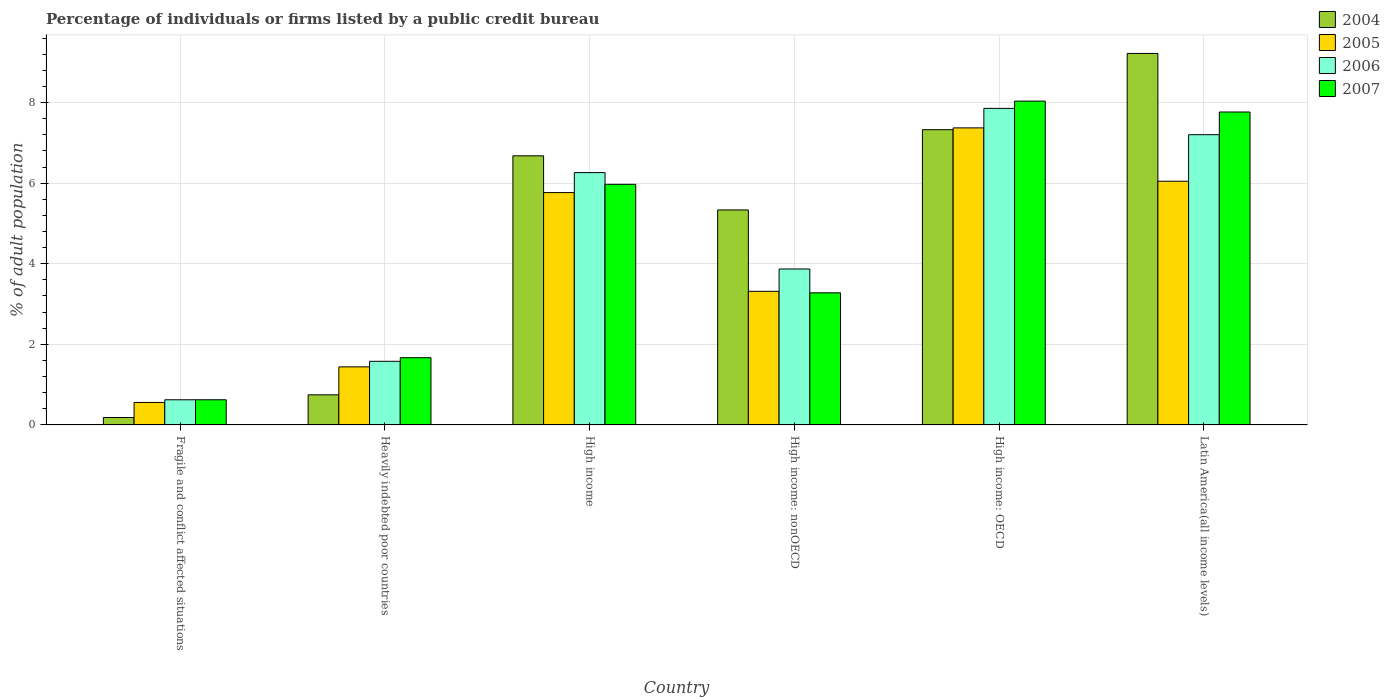How many different coloured bars are there?
Offer a very short reply. 4. How many bars are there on the 4th tick from the left?
Keep it short and to the point. 4. How many bars are there on the 3rd tick from the right?
Offer a terse response. 4. What is the label of the 2nd group of bars from the left?
Your answer should be compact. Heavily indebted poor countries. In how many cases, is the number of bars for a given country not equal to the number of legend labels?
Your response must be concise. 0. What is the percentage of population listed by a public credit bureau in 2007 in High income: nonOECD?
Your answer should be compact. 3.28. Across all countries, what is the maximum percentage of population listed by a public credit bureau in 2007?
Provide a succinct answer. 8.04. Across all countries, what is the minimum percentage of population listed by a public credit bureau in 2004?
Offer a terse response. 0.18. In which country was the percentage of population listed by a public credit bureau in 2006 maximum?
Ensure brevity in your answer.  High income: OECD. In which country was the percentage of population listed by a public credit bureau in 2005 minimum?
Your answer should be very brief. Fragile and conflict affected situations. What is the total percentage of population listed by a public credit bureau in 2004 in the graph?
Give a very brief answer. 29.49. What is the difference between the percentage of population listed by a public credit bureau in 2006 in Fragile and conflict affected situations and that in High income: OECD?
Your answer should be compact. -7.23. What is the difference between the percentage of population listed by a public credit bureau in 2005 in Fragile and conflict affected situations and the percentage of population listed by a public credit bureau in 2007 in Heavily indebted poor countries?
Provide a succinct answer. -1.11. What is the average percentage of population listed by a public credit bureau in 2005 per country?
Keep it short and to the point. 4.08. What is the difference between the percentage of population listed by a public credit bureau of/in 2007 and percentage of population listed by a public credit bureau of/in 2004 in Fragile and conflict affected situations?
Provide a succinct answer. 0.44. What is the ratio of the percentage of population listed by a public credit bureau in 2006 in High income: OECD to that in High income: nonOECD?
Keep it short and to the point. 2.03. Is the difference between the percentage of population listed by a public credit bureau in 2007 in Heavily indebted poor countries and High income greater than the difference between the percentage of population listed by a public credit bureau in 2004 in Heavily indebted poor countries and High income?
Offer a terse response. Yes. What is the difference between the highest and the second highest percentage of population listed by a public credit bureau in 2005?
Keep it short and to the point. -0.28. What is the difference between the highest and the lowest percentage of population listed by a public credit bureau in 2004?
Your response must be concise. 9.04. In how many countries, is the percentage of population listed by a public credit bureau in 2007 greater than the average percentage of population listed by a public credit bureau in 2007 taken over all countries?
Ensure brevity in your answer.  3. Is the sum of the percentage of population listed by a public credit bureau in 2007 in High income and Latin America(all income levels) greater than the maximum percentage of population listed by a public credit bureau in 2006 across all countries?
Your response must be concise. Yes. What does the 4th bar from the left in Latin America(all income levels) represents?
Provide a short and direct response. 2007. What does the 2nd bar from the right in High income represents?
Your answer should be compact. 2006. Is it the case that in every country, the sum of the percentage of population listed by a public credit bureau in 2007 and percentage of population listed by a public credit bureau in 2005 is greater than the percentage of population listed by a public credit bureau in 2006?
Keep it short and to the point. Yes. How many countries are there in the graph?
Provide a short and direct response. 6. What is the difference between two consecutive major ticks on the Y-axis?
Offer a very short reply. 2. Are the values on the major ticks of Y-axis written in scientific E-notation?
Keep it short and to the point. No. Does the graph contain any zero values?
Your response must be concise. No. How many legend labels are there?
Provide a succinct answer. 4. How are the legend labels stacked?
Make the answer very short. Vertical. What is the title of the graph?
Make the answer very short. Percentage of individuals or firms listed by a public credit bureau. What is the label or title of the X-axis?
Provide a succinct answer. Country. What is the label or title of the Y-axis?
Give a very brief answer. % of adult population. What is the % of adult population of 2004 in Fragile and conflict affected situations?
Offer a terse response. 0.18. What is the % of adult population in 2005 in Fragile and conflict affected situations?
Make the answer very short. 0.56. What is the % of adult population of 2006 in Fragile and conflict affected situations?
Your response must be concise. 0.62. What is the % of adult population in 2007 in Fragile and conflict affected situations?
Provide a short and direct response. 0.62. What is the % of adult population of 2004 in Heavily indebted poor countries?
Your answer should be very brief. 0.75. What is the % of adult population in 2005 in Heavily indebted poor countries?
Your answer should be compact. 1.44. What is the % of adult population in 2006 in Heavily indebted poor countries?
Make the answer very short. 1.58. What is the % of adult population in 2007 in Heavily indebted poor countries?
Offer a terse response. 1.67. What is the % of adult population of 2004 in High income?
Ensure brevity in your answer.  6.68. What is the % of adult population of 2005 in High income?
Give a very brief answer. 5.77. What is the % of adult population of 2006 in High income?
Give a very brief answer. 6.26. What is the % of adult population in 2007 in High income?
Provide a succinct answer. 5.97. What is the % of adult population in 2004 in High income: nonOECD?
Give a very brief answer. 5.34. What is the % of adult population in 2005 in High income: nonOECD?
Offer a very short reply. 3.32. What is the % of adult population in 2006 in High income: nonOECD?
Offer a terse response. 3.87. What is the % of adult population in 2007 in High income: nonOECD?
Your response must be concise. 3.28. What is the % of adult population in 2004 in High income: OECD?
Your answer should be very brief. 7.33. What is the % of adult population in 2005 in High income: OECD?
Your response must be concise. 7.37. What is the % of adult population of 2006 in High income: OECD?
Your answer should be very brief. 7.86. What is the % of adult population in 2007 in High income: OECD?
Your answer should be compact. 8.04. What is the % of adult population in 2004 in Latin America(all income levels)?
Ensure brevity in your answer.  9.22. What is the % of adult population of 2005 in Latin America(all income levels)?
Keep it short and to the point. 6.05. What is the % of adult population of 2006 in Latin America(all income levels)?
Offer a terse response. 7.2. What is the % of adult population of 2007 in Latin America(all income levels)?
Ensure brevity in your answer.  7.77. Across all countries, what is the maximum % of adult population in 2004?
Keep it short and to the point. 9.22. Across all countries, what is the maximum % of adult population of 2005?
Your response must be concise. 7.37. Across all countries, what is the maximum % of adult population in 2006?
Give a very brief answer. 7.86. Across all countries, what is the maximum % of adult population of 2007?
Keep it short and to the point. 8.04. Across all countries, what is the minimum % of adult population in 2004?
Make the answer very short. 0.18. Across all countries, what is the minimum % of adult population in 2005?
Your answer should be very brief. 0.56. Across all countries, what is the minimum % of adult population of 2006?
Offer a terse response. 0.62. Across all countries, what is the minimum % of adult population in 2007?
Your answer should be very brief. 0.62. What is the total % of adult population of 2004 in the graph?
Offer a terse response. 29.49. What is the total % of adult population of 2005 in the graph?
Your answer should be very brief. 24.5. What is the total % of adult population of 2006 in the graph?
Provide a succinct answer. 27.4. What is the total % of adult population of 2007 in the graph?
Provide a succinct answer. 27.35. What is the difference between the % of adult population in 2004 in Fragile and conflict affected situations and that in Heavily indebted poor countries?
Provide a short and direct response. -0.56. What is the difference between the % of adult population of 2005 in Fragile and conflict affected situations and that in Heavily indebted poor countries?
Ensure brevity in your answer.  -0.88. What is the difference between the % of adult population of 2006 in Fragile and conflict affected situations and that in Heavily indebted poor countries?
Give a very brief answer. -0.95. What is the difference between the % of adult population in 2007 in Fragile and conflict affected situations and that in Heavily indebted poor countries?
Give a very brief answer. -1.04. What is the difference between the % of adult population of 2004 in Fragile and conflict affected situations and that in High income?
Provide a succinct answer. -6.5. What is the difference between the % of adult population of 2005 in Fragile and conflict affected situations and that in High income?
Offer a terse response. -5.21. What is the difference between the % of adult population in 2006 in Fragile and conflict affected situations and that in High income?
Give a very brief answer. -5.64. What is the difference between the % of adult population in 2007 in Fragile and conflict affected situations and that in High income?
Offer a very short reply. -5.35. What is the difference between the % of adult population in 2004 in Fragile and conflict affected situations and that in High income: nonOECD?
Make the answer very short. -5.15. What is the difference between the % of adult population of 2005 in Fragile and conflict affected situations and that in High income: nonOECD?
Offer a terse response. -2.76. What is the difference between the % of adult population in 2006 in Fragile and conflict affected situations and that in High income: nonOECD?
Offer a terse response. -3.25. What is the difference between the % of adult population of 2007 in Fragile and conflict affected situations and that in High income: nonOECD?
Your answer should be very brief. -2.65. What is the difference between the % of adult population of 2004 in Fragile and conflict affected situations and that in High income: OECD?
Your answer should be compact. -7.14. What is the difference between the % of adult population in 2005 in Fragile and conflict affected situations and that in High income: OECD?
Offer a very short reply. -6.82. What is the difference between the % of adult population in 2006 in Fragile and conflict affected situations and that in High income: OECD?
Offer a terse response. -7.23. What is the difference between the % of adult population in 2007 in Fragile and conflict affected situations and that in High income: OECD?
Provide a succinct answer. -7.41. What is the difference between the % of adult population in 2004 in Fragile and conflict affected situations and that in Latin America(all income levels)?
Your answer should be very brief. -9.04. What is the difference between the % of adult population in 2005 in Fragile and conflict affected situations and that in Latin America(all income levels)?
Provide a succinct answer. -5.49. What is the difference between the % of adult population in 2006 in Fragile and conflict affected situations and that in Latin America(all income levels)?
Provide a short and direct response. -6.58. What is the difference between the % of adult population in 2007 in Fragile and conflict affected situations and that in Latin America(all income levels)?
Your response must be concise. -7.14. What is the difference between the % of adult population in 2004 in Heavily indebted poor countries and that in High income?
Ensure brevity in your answer.  -5.93. What is the difference between the % of adult population in 2005 in Heavily indebted poor countries and that in High income?
Provide a succinct answer. -4.33. What is the difference between the % of adult population in 2006 in Heavily indebted poor countries and that in High income?
Make the answer very short. -4.68. What is the difference between the % of adult population in 2007 in Heavily indebted poor countries and that in High income?
Provide a short and direct response. -4.3. What is the difference between the % of adult population in 2004 in Heavily indebted poor countries and that in High income: nonOECD?
Offer a terse response. -4.59. What is the difference between the % of adult population in 2005 in Heavily indebted poor countries and that in High income: nonOECD?
Provide a short and direct response. -1.88. What is the difference between the % of adult population in 2006 in Heavily indebted poor countries and that in High income: nonOECD?
Your answer should be very brief. -2.29. What is the difference between the % of adult population in 2007 in Heavily indebted poor countries and that in High income: nonOECD?
Your answer should be compact. -1.61. What is the difference between the % of adult population of 2004 in Heavily indebted poor countries and that in High income: OECD?
Provide a succinct answer. -6.58. What is the difference between the % of adult population of 2005 in Heavily indebted poor countries and that in High income: OECD?
Your answer should be compact. -5.93. What is the difference between the % of adult population of 2006 in Heavily indebted poor countries and that in High income: OECD?
Give a very brief answer. -6.28. What is the difference between the % of adult population of 2007 in Heavily indebted poor countries and that in High income: OECD?
Your answer should be very brief. -6.37. What is the difference between the % of adult population in 2004 in Heavily indebted poor countries and that in Latin America(all income levels)?
Offer a terse response. -8.47. What is the difference between the % of adult population of 2005 in Heavily indebted poor countries and that in Latin America(all income levels)?
Provide a short and direct response. -4.61. What is the difference between the % of adult population in 2006 in Heavily indebted poor countries and that in Latin America(all income levels)?
Offer a very short reply. -5.62. What is the difference between the % of adult population in 2007 in Heavily indebted poor countries and that in Latin America(all income levels)?
Provide a succinct answer. -6.1. What is the difference between the % of adult population in 2004 in High income and that in High income: nonOECD?
Provide a short and direct response. 1.34. What is the difference between the % of adult population of 2005 in High income and that in High income: nonOECD?
Provide a succinct answer. 2.45. What is the difference between the % of adult population in 2006 in High income and that in High income: nonOECD?
Ensure brevity in your answer.  2.39. What is the difference between the % of adult population in 2007 in High income and that in High income: nonOECD?
Give a very brief answer. 2.69. What is the difference between the % of adult population of 2004 in High income and that in High income: OECD?
Provide a short and direct response. -0.65. What is the difference between the % of adult population in 2005 in High income and that in High income: OECD?
Offer a very short reply. -1.61. What is the difference between the % of adult population in 2006 in High income and that in High income: OECD?
Provide a short and direct response. -1.59. What is the difference between the % of adult population of 2007 in High income and that in High income: OECD?
Ensure brevity in your answer.  -2.06. What is the difference between the % of adult population of 2004 in High income and that in Latin America(all income levels)?
Ensure brevity in your answer.  -2.54. What is the difference between the % of adult population in 2005 in High income and that in Latin America(all income levels)?
Your answer should be compact. -0.28. What is the difference between the % of adult population of 2006 in High income and that in Latin America(all income levels)?
Your response must be concise. -0.94. What is the difference between the % of adult population of 2007 in High income and that in Latin America(all income levels)?
Offer a very short reply. -1.79. What is the difference between the % of adult population in 2004 in High income: nonOECD and that in High income: OECD?
Your answer should be very brief. -1.99. What is the difference between the % of adult population in 2005 in High income: nonOECD and that in High income: OECD?
Make the answer very short. -4.06. What is the difference between the % of adult population of 2006 in High income: nonOECD and that in High income: OECD?
Your answer should be compact. -3.99. What is the difference between the % of adult population of 2007 in High income: nonOECD and that in High income: OECD?
Your response must be concise. -4.76. What is the difference between the % of adult population in 2004 in High income: nonOECD and that in Latin America(all income levels)?
Your answer should be compact. -3.88. What is the difference between the % of adult population of 2005 in High income: nonOECD and that in Latin America(all income levels)?
Ensure brevity in your answer.  -2.73. What is the difference between the % of adult population of 2006 in High income: nonOECD and that in Latin America(all income levels)?
Provide a short and direct response. -3.33. What is the difference between the % of adult population in 2007 in High income: nonOECD and that in Latin America(all income levels)?
Your answer should be very brief. -4.49. What is the difference between the % of adult population of 2004 in High income: OECD and that in Latin America(all income levels)?
Offer a terse response. -1.89. What is the difference between the % of adult population of 2005 in High income: OECD and that in Latin America(all income levels)?
Your answer should be very brief. 1.32. What is the difference between the % of adult population in 2006 in High income: OECD and that in Latin America(all income levels)?
Offer a very short reply. 0.65. What is the difference between the % of adult population in 2007 in High income: OECD and that in Latin America(all income levels)?
Offer a very short reply. 0.27. What is the difference between the % of adult population of 2004 in Fragile and conflict affected situations and the % of adult population of 2005 in Heavily indebted poor countries?
Your answer should be very brief. -1.26. What is the difference between the % of adult population of 2004 in Fragile and conflict affected situations and the % of adult population of 2006 in Heavily indebted poor countries?
Provide a succinct answer. -1.39. What is the difference between the % of adult population in 2004 in Fragile and conflict affected situations and the % of adult population in 2007 in Heavily indebted poor countries?
Keep it short and to the point. -1.48. What is the difference between the % of adult population in 2005 in Fragile and conflict affected situations and the % of adult population in 2006 in Heavily indebted poor countries?
Keep it short and to the point. -1.02. What is the difference between the % of adult population in 2005 in Fragile and conflict affected situations and the % of adult population in 2007 in Heavily indebted poor countries?
Your response must be concise. -1.11. What is the difference between the % of adult population of 2006 in Fragile and conflict affected situations and the % of adult population of 2007 in Heavily indebted poor countries?
Give a very brief answer. -1.04. What is the difference between the % of adult population in 2004 in Fragile and conflict affected situations and the % of adult population in 2005 in High income?
Offer a terse response. -5.58. What is the difference between the % of adult population in 2004 in Fragile and conflict affected situations and the % of adult population in 2006 in High income?
Keep it short and to the point. -6.08. What is the difference between the % of adult population of 2004 in Fragile and conflict affected situations and the % of adult population of 2007 in High income?
Give a very brief answer. -5.79. What is the difference between the % of adult population in 2005 in Fragile and conflict affected situations and the % of adult population in 2006 in High income?
Ensure brevity in your answer.  -5.7. What is the difference between the % of adult population in 2005 in Fragile and conflict affected situations and the % of adult population in 2007 in High income?
Offer a very short reply. -5.41. What is the difference between the % of adult population of 2006 in Fragile and conflict affected situations and the % of adult population of 2007 in High income?
Your response must be concise. -5.35. What is the difference between the % of adult population of 2004 in Fragile and conflict affected situations and the % of adult population of 2005 in High income: nonOECD?
Provide a short and direct response. -3.13. What is the difference between the % of adult population of 2004 in Fragile and conflict affected situations and the % of adult population of 2006 in High income: nonOECD?
Make the answer very short. -3.69. What is the difference between the % of adult population of 2004 in Fragile and conflict affected situations and the % of adult population of 2007 in High income: nonOECD?
Make the answer very short. -3.09. What is the difference between the % of adult population in 2005 in Fragile and conflict affected situations and the % of adult population in 2006 in High income: nonOECD?
Provide a short and direct response. -3.31. What is the difference between the % of adult population in 2005 in Fragile and conflict affected situations and the % of adult population in 2007 in High income: nonOECD?
Provide a short and direct response. -2.72. What is the difference between the % of adult population of 2006 in Fragile and conflict affected situations and the % of adult population of 2007 in High income: nonOECD?
Your answer should be very brief. -2.65. What is the difference between the % of adult population in 2004 in Fragile and conflict affected situations and the % of adult population in 2005 in High income: OECD?
Offer a terse response. -7.19. What is the difference between the % of adult population of 2004 in Fragile and conflict affected situations and the % of adult population of 2006 in High income: OECD?
Your answer should be very brief. -7.67. What is the difference between the % of adult population of 2004 in Fragile and conflict affected situations and the % of adult population of 2007 in High income: OECD?
Your answer should be very brief. -7.85. What is the difference between the % of adult population in 2005 in Fragile and conflict affected situations and the % of adult population in 2006 in High income: OECD?
Keep it short and to the point. -7.3. What is the difference between the % of adult population of 2005 in Fragile and conflict affected situations and the % of adult population of 2007 in High income: OECD?
Ensure brevity in your answer.  -7.48. What is the difference between the % of adult population of 2006 in Fragile and conflict affected situations and the % of adult population of 2007 in High income: OECD?
Offer a terse response. -7.41. What is the difference between the % of adult population in 2004 in Fragile and conflict affected situations and the % of adult population in 2005 in Latin America(all income levels)?
Provide a short and direct response. -5.86. What is the difference between the % of adult population of 2004 in Fragile and conflict affected situations and the % of adult population of 2006 in Latin America(all income levels)?
Keep it short and to the point. -7.02. What is the difference between the % of adult population in 2004 in Fragile and conflict affected situations and the % of adult population in 2007 in Latin America(all income levels)?
Give a very brief answer. -7.58. What is the difference between the % of adult population in 2005 in Fragile and conflict affected situations and the % of adult population in 2006 in Latin America(all income levels)?
Your answer should be compact. -6.65. What is the difference between the % of adult population in 2005 in Fragile and conflict affected situations and the % of adult population in 2007 in Latin America(all income levels)?
Your answer should be compact. -7.21. What is the difference between the % of adult population of 2006 in Fragile and conflict affected situations and the % of adult population of 2007 in Latin America(all income levels)?
Provide a short and direct response. -7.14. What is the difference between the % of adult population of 2004 in Heavily indebted poor countries and the % of adult population of 2005 in High income?
Offer a terse response. -5.02. What is the difference between the % of adult population in 2004 in Heavily indebted poor countries and the % of adult population in 2006 in High income?
Make the answer very short. -5.51. What is the difference between the % of adult population in 2004 in Heavily indebted poor countries and the % of adult population in 2007 in High income?
Offer a terse response. -5.22. What is the difference between the % of adult population of 2005 in Heavily indebted poor countries and the % of adult population of 2006 in High income?
Offer a very short reply. -4.82. What is the difference between the % of adult population of 2005 in Heavily indebted poor countries and the % of adult population of 2007 in High income?
Your answer should be very brief. -4.53. What is the difference between the % of adult population in 2006 in Heavily indebted poor countries and the % of adult population in 2007 in High income?
Provide a short and direct response. -4.39. What is the difference between the % of adult population of 2004 in Heavily indebted poor countries and the % of adult population of 2005 in High income: nonOECD?
Provide a succinct answer. -2.57. What is the difference between the % of adult population in 2004 in Heavily indebted poor countries and the % of adult population in 2006 in High income: nonOECD?
Give a very brief answer. -3.12. What is the difference between the % of adult population of 2004 in Heavily indebted poor countries and the % of adult population of 2007 in High income: nonOECD?
Your answer should be compact. -2.53. What is the difference between the % of adult population of 2005 in Heavily indebted poor countries and the % of adult population of 2006 in High income: nonOECD?
Provide a short and direct response. -2.43. What is the difference between the % of adult population in 2005 in Heavily indebted poor countries and the % of adult population in 2007 in High income: nonOECD?
Offer a very short reply. -1.84. What is the difference between the % of adult population of 2006 in Heavily indebted poor countries and the % of adult population of 2007 in High income: nonOECD?
Ensure brevity in your answer.  -1.7. What is the difference between the % of adult population in 2004 in Heavily indebted poor countries and the % of adult population in 2005 in High income: OECD?
Keep it short and to the point. -6.63. What is the difference between the % of adult population of 2004 in Heavily indebted poor countries and the % of adult population of 2006 in High income: OECD?
Ensure brevity in your answer.  -7.11. What is the difference between the % of adult population of 2004 in Heavily indebted poor countries and the % of adult population of 2007 in High income: OECD?
Your response must be concise. -7.29. What is the difference between the % of adult population in 2005 in Heavily indebted poor countries and the % of adult population in 2006 in High income: OECD?
Your response must be concise. -6.42. What is the difference between the % of adult population in 2005 in Heavily indebted poor countries and the % of adult population in 2007 in High income: OECD?
Your answer should be very brief. -6.6. What is the difference between the % of adult population of 2006 in Heavily indebted poor countries and the % of adult population of 2007 in High income: OECD?
Ensure brevity in your answer.  -6.46. What is the difference between the % of adult population in 2004 in Heavily indebted poor countries and the % of adult population in 2005 in Latin America(all income levels)?
Provide a short and direct response. -5.3. What is the difference between the % of adult population in 2004 in Heavily indebted poor countries and the % of adult population in 2006 in Latin America(all income levels)?
Provide a short and direct response. -6.46. What is the difference between the % of adult population of 2004 in Heavily indebted poor countries and the % of adult population of 2007 in Latin America(all income levels)?
Give a very brief answer. -7.02. What is the difference between the % of adult population in 2005 in Heavily indebted poor countries and the % of adult population in 2006 in Latin America(all income levels)?
Offer a terse response. -5.76. What is the difference between the % of adult population in 2005 in Heavily indebted poor countries and the % of adult population in 2007 in Latin America(all income levels)?
Make the answer very short. -6.33. What is the difference between the % of adult population of 2006 in Heavily indebted poor countries and the % of adult population of 2007 in Latin America(all income levels)?
Your answer should be compact. -6.19. What is the difference between the % of adult population of 2004 in High income and the % of adult population of 2005 in High income: nonOECD?
Your answer should be very brief. 3.36. What is the difference between the % of adult population of 2004 in High income and the % of adult population of 2006 in High income: nonOECD?
Keep it short and to the point. 2.81. What is the difference between the % of adult population of 2004 in High income and the % of adult population of 2007 in High income: nonOECD?
Your answer should be compact. 3.4. What is the difference between the % of adult population in 2005 in High income and the % of adult population in 2006 in High income: nonOECD?
Your response must be concise. 1.9. What is the difference between the % of adult population in 2005 in High income and the % of adult population in 2007 in High income: nonOECD?
Your answer should be compact. 2.49. What is the difference between the % of adult population in 2006 in High income and the % of adult population in 2007 in High income: nonOECD?
Make the answer very short. 2.98. What is the difference between the % of adult population of 2004 in High income and the % of adult population of 2005 in High income: OECD?
Provide a short and direct response. -0.69. What is the difference between the % of adult population in 2004 in High income and the % of adult population in 2006 in High income: OECD?
Provide a succinct answer. -1.18. What is the difference between the % of adult population in 2004 in High income and the % of adult population in 2007 in High income: OECD?
Your answer should be very brief. -1.36. What is the difference between the % of adult population of 2005 in High income and the % of adult population of 2006 in High income: OECD?
Provide a short and direct response. -2.09. What is the difference between the % of adult population of 2005 in High income and the % of adult population of 2007 in High income: OECD?
Your response must be concise. -2.27. What is the difference between the % of adult population of 2006 in High income and the % of adult population of 2007 in High income: OECD?
Offer a very short reply. -1.77. What is the difference between the % of adult population of 2004 in High income and the % of adult population of 2005 in Latin America(all income levels)?
Offer a very short reply. 0.63. What is the difference between the % of adult population in 2004 in High income and the % of adult population in 2006 in Latin America(all income levels)?
Offer a very short reply. -0.52. What is the difference between the % of adult population in 2004 in High income and the % of adult population in 2007 in Latin America(all income levels)?
Give a very brief answer. -1.09. What is the difference between the % of adult population of 2005 in High income and the % of adult population of 2006 in Latin America(all income levels)?
Give a very brief answer. -1.44. What is the difference between the % of adult population of 2006 in High income and the % of adult population of 2007 in Latin America(all income levels)?
Provide a succinct answer. -1.5. What is the difference between the % of adult population of 2004 in High income: nonOECD and the % of adult population of 2005 in High income: OECD?
Give a very brief answer. -2.04. What is the difference between the % of adult population of 2004 in High income: nonOECD and the % of adult population of 2006 in High income: OECD?
Your answer should be compact. -2.52. What is the difference between the % of adult population in 2004 in High income: nonOECD and the % of adult population in 2007 in High income: OECD?
Keep it short and to the point. -2.7. What is the difference between the % of adult population in 2005 in High income: nonOECD and the % of adult population in 2006 in High income: OECD?
Offer a very short reply. -4.54. What is the difference between the % of adult population of 2005 in High income: nonOECD and the % of adult population of 2007 in High income: OECD?
Offer a very short reply. -4.72. What is the difference between the % of adult population of 2006 in High income: nonOECD and the % of adult population of 2007 in High income: OECD?
Your response must be concise. -4.17. What is the difference between the % of adult population in 2004 in High income: nonOECD and the % of adult population in 2005 in Latin America(all income levels)?
Your response must be concise. -0.71. What is the difference between the % of adult population of 2004 in High income: nonOECD and the % of adult population of 2006 in Latin America(all income levels)?
Make the answer very short. -1.87. What is the difference between the % of adult population in 2004 in High income: nonOECD and the % of adult population in 2007 in Latin America(all income levels)?
Make the answer very short. -2.43. What is the difference between the % of adult population of 2005 in High income: nonOECD and the % of adult population of 2006 in Latin America(all income levels)?
Offer a very short reply. -3.89. What is the difference between the % of adult population in 2005 in High income: nonOECD and the % of adult population in 2007 in Latin America(all income levels)?
Your answer should be compact. -4.45. What is the difference between the % of adult population in 2006 in High income: nonOECD and the % of adult population in 2007 in Latin America(all income levels)?
Your answer should be very brief. -3.9. What is the difference between the % of adult population in 2004 in High income: OECD and the % of adult population in 2005 in Latin America(all income levels)?
Offer a very short reply. 1.28. What is the difference between the % of adult population in 2004 in High income: OECD and the % of adult population in 2006 in Latin America(all income levels)?
Offer a terse response. 0.12. What is the difference between the % of adult population in 2004 in High income: OECD and the % of adult population in 2007 in Latin America(all income levels)?
Provide a short and direct response. -0.44. What is the difference between the % of adult population of 2005 in High income: OECD and the % of adult population of 2006 in Latin America(all income levels)?
Your answer should be compact. 0.17. What is the difference between the % of adult population of 2005 in High income: OECD and the % of adult population of 2007 in Latin America(all income levels)?
Your answer should be compact. -0.39. What is the difference between the % of adult population in 2006 in High income: OECD and the % of adult population in 2007 in Latin America(all income levels)?
Ensure brevity in your answer.  0.09. What is the average % of adult population of 2004 per country?
Keep it short and to the point. 4.92. What is the average % of adult population of 2005 per country?
Your response must be concise. 4.08. What is the average % of adult population of 2006 per country?
Offer a terse response. 4.57. What is the average % of adult population in 2007 per country?
Your answer should be very brief. 4.56. What is the difference between the % of adult population of 2004 and % of adult population of 2005 in Fragile and conflict affected situations?
Keep it short and to the point. -0.37. What is the difference between the % of adult population of 2004 and % of adult population of 2006 in Fragile and conflict affected situations?
Offer a terse response. -0.44. What is the difference between the % of adult population of 2004 and % of adult population of 2007 in Fragile and conflict affected situations?
Ensure brevity in your answer.  -0.44. What is the difference between the % of adult population of 2005 and % of adult population of 2006 in Fragile and conflict affected situations?
Offer a very short reply. -0.07. What is the difference between the % of adult population in 2005 and % of adult population in 2007 in Fragile and conflict affected situations?
Offer a terse response. -0.07. What is the difference between the % of adult population in 2004 and % of adult population in 2005 in Heavily indebted poor countries?
Offer a very short reply. -0.69. What is the difference between the % of adult population in 2004 and % of adult population in 2006 in Heavily indebted poor countries?
Your answer should be compact. -0.83. What is the difference between the % of adult population of 2004 and % of adult population of 2007 in Heavily indebted poor countries?
Your answer should be compact. -0.92. What is the difference between the % of adult population in 2005 and % of adult population in 2006 in Heavily indebted poor countries?
Your answer should be compact. -0.14. What is the difference between the % of adult population in 2005 and % of adult population in 2007 in Heavily indebted poor countries?
Provide a short and direct response. -0.23. What is the difference between the % of adult population in 2006 and % of adult population in 2007 in Heavily indebted poor countries?
Provide a succinct answer. -0.09. What is the difference between the % of adult population of 2004 and % of adult population of 2005 in High income?
Keep it short and to the point. 0.91. What is the difference between the % of adult population in 2004 and % of adult population in 2006 in High income?
Your answer should be very brief. 0.42. What is the difference between the % of adult population in 2004 and % of adult population in 2007 in High income?
Your response must be concise. 0.71. What is the difference between the % of adult population in 2005 and % of adult population in 2006 in High income?
Make the answer very short. -0.5. What is the difference between the % of adult population in 2005 and % of adult population in 2007 in High income?
Your answer should be very brief. -0.2. What is the difference between the % of adult population in 2006 and % of adult population in 2007 in High income?
Ensure brevity in your answer.  0.29. What is the difference between the % of adult population in 2004 and % of adult population in 2005 in High income: nonOECD?
Make the answer very short. 2.02. What is the difference between the % of adult population in 2004 and % of adult population in 2006 in High income: nonOECD?
Provide a short and direct response. 1.47. What is the difference between the % of adult population in 2004 and % of adult population in 2007 in High income: nonOECD?
Give a very brief answer. 2.06. What is the difference between the % of adult population in 2005 and % of adult population in 2006 in High income: nonOECD?
Offer a very short reply. -0.55. What is the difference between the % of adult population of 2005 and % of adult population of 2007 in High income: nonOECD?
Provide a succinct answer. 0.04. What is the difference between the % of adult population in 2006 and % of adult population in 2007 in High income: nonOECD?
Your response must be concise. 0.59. What is the difference between the % of adult population in 2004 and % of adult population in 2005 in High income: OECD?
Keep it short and to the point. -0.04. What is the difference between the % of adult population of 2004 and % of adult population of 2006 in High income: OECD?
Make the answer very short. -0.53. What is the difference between the % of adult population of 2004 and % of adult population of 2007 in High income: OECD?
Ensure brevity in your answer.  -0.71. What is the difference between the % of adult population of 2005 and % of adult population of 2006 in High income: OECD?
Keep it short and to the point. -0.48. What is the difference between the % of adult population of 2005 and % of adult population of 2007 in High income: OECD?
Your answer should be compact. -0.66. What is the difference between the % of adult population in 2006 and % of adult population in 2007 in High income: OECD?
Your answer should be compact. -0.18. What is the difference between the % of adult population of 2004 and % of adult population of 2005 in Latin America(all income levels)?
Make the answer very short. 3.17. What is the difference between the % of adult population in 2004 and % of adult population in 2006 in Latin America(all income levels)?
Make the answer very short. 2.02. What is the difference between the % of adult population of 2004 and % of adult population of 2007 in Latin America(all income levels)?
Keep it short and to the point. 1.45. What is the difference between the % of adult population in 2005 and % of adult population in 2006 in Latin America(all income levels)?
Offer a terse response. -1.16. What is the difference between the % of adult population in 2005 and % of adult population in 2007 in Latin America(all income levels)?
Offer a terse response. -1.72. What is the difference between the % of adult population of 2006 and % of adult population of 2007 in Latin America(all income levels)?
Your response must be concise. -0.56. What is the ratio of the % of adult population of 2004 in Fragile and conflict affected situations to that in Heavily indebted poor countries?
Give a very brief answer. 0.25. What is the ratio of the % of adult population of 2005 in Fragile and conflict affected situations to that in Heavily indebted poor countries?
Keep it short and to the point. 0.39. What is the ratio of the % of adult population in 2006 in Fragile and conflict affected situations to that in Heavily indebted poor countries?
Offer a very short reply. 0.4. What is the ratio of the % of adult population of 2007 in Fragile and conflict affected situations to that in Heavily indebted poor countries?
Ensure brevity in your answer.  0.37. What is the ratio of the % of adult population of 2004 in Fragile and conflict affected situations to that in High income?
Offer a very short reply. 0.03. What is the ratio of the % of adult population of 2005 in Fragile and conflict affected situations to that in High income?
Offer a terse response. 0.1. What is the ratio of the % of adult population in 2006 in Fragile and conflict affected situations to that in High income?
Offer a very short reply. 0.1. What is the ratio of the % of adult population of 2007 in Fragile and conflict affected situations to that in High income?
Offer a very short reply. 0.1. What is the ratio of the % of adult population of 2004 in Fragile and conflict affected situations to that in High income: nonOECD?
Ensure brevity in your answer.  0.03. What is the ratio of the % of adult population of 2005 in Fragile and conflict affected situations to that in High income: nonOECD?
Ensure brevity in your answer.  0.17. What is the ratio of the % of adult population in 2006 in Fragile and conflict affected situations to that in High income: nonOECD?
Give a very brief answer. 0.16. What is the ratio of the % of adult population of 2007 in Fragile and conflict affected situations to that in High income: nonOECD?
Keep it short and to the point. 0.19. What is the ratio of the % of adult population of 2004 in Fragile and conflict affected situations to that in High income: OECD?
Make the answer very short. 0.03. What is the ratio of the % of adult population of 2005 in Fragile and conflict affected situations to that in High income: OECD?
Make the answer very short. 0.08. What is the ratio of the % of adult population of 2006 in Fragile and conflict affected situations to that in High income: OECD?
Offer a terse response. 0.08. What is the ratio of the % of adult population of 2007 in Fragile and conflict affected situations to that in High income: OECD?
Ensure brevity in your answer.  0.08. What is the ratio of the % of adult population of 2004 in Fragile and conflict affected situations to that in Latin America(all income levels)?
Your answer should be very brief. 0.02. What is the ratio of the % of adult population of 2005 in Fragile and conflict affected situations to that in Latin America(all income levels)?
Offer a very short reply. 0.09. What is the ratio of the % of adult population of 2006 in Fragile and conflict affected situations to that in Latin America(all income levels)?
Offer a terse response. 0.09. What is the ratio of the % of adult population in 2007 in Fragile and conflict affected situations to that in Latin America(all income levels)?
Provide a succinct answer. 0.08. What is the ratio of the % of adult population in 2004 in Heavily indebted poor countries to that in High income?
Give a very brief answer. 0.11. What is the ratio of the % of adult population of 2005 in Heavily indebted poor countries to that in High income?
Offer a very short reply. 0.25. What is the ratio of the % of adult population in 2006 in Heavily indebted poor countries to that in High income?
Keep it short and to the point. 0.25. What is the ratio of the % of adult population in 2007 in Heavily indebted poor countries to that in High income?
Make the answer very short. 0.28. What is the ratio of the % of adult population in 2004 in Heavily indebted poor countries to that in High income: nonOECD?
Offer a very short reply. 0.14. What is the ratio of the % of adult population of 2005 in Heavily indebted poor countries to that in High income: nonOECD?
Your response must be concise. 0.43. What is the ratio of the % of adult population of 2006 in Heavily indebted poor countries to that in High income: nonOECD?
Offer a terse response. 0.41. What is the ratio of the % of adult population in 2007 in Heavily indebted poor countries to that in High income: nonOECD?
Offer a terse response. 0.51. What is the ratio of the % of adult population in 2004 in Heavily indebted poor countries to that in High income: OECD?
Give a very brief answer. 0.1. What is the ratio of the % of adult population of 2005 in Heavily indebted poor countries to that in High income: OECD?
Give a very brief answer. 0.2. What is the ratio of the % of adult population of 2006 in Heavily indebted poor countries to that in High income: OECD?
Your answer should be very brief. 0.2. What is the ratio of the % of adult population in 2007 in Heavily indebted poor countries to that in High income: OECD?
Provide a succinct answer. 0.21. What is the ratio of the % of adult population in 2004 in Heavily indebted poor countries to that in Latin America(all income levels)?
Offer a terse response. 0.08. What is the ratio of the % of adult population of 2005 in Heavily indebted poor countries to that in Latin America(all income levels)?
Provide a succinct answer. 0.24. What is the ratio of the % of adult population of 2006 in Heavily indebted poor countries to that in Latin America(all income levels)?
Your answer should be very brief. 0.22. What is the ratio of the % of adult population in 2007 in Heavily indebted poor countries to that in Latin America(all income levels)?
Your answer should be very brief. 0.21. What is the ratio of the % of adult population in 2004 in High income to that in High income: nonOECD?
Keep it short and to the point. 1.25. What is the ratio of the % of adult population of 2005 in High income to that in High income: nonOECD?
Your answer should be very brief. 1.74. What is the ratio of the % of adult population in 2006 in High income to that in High income: nonOECD?
Keep it short and to the point. 1.62. What is the ratio of the % of adult population of 2007 in High income to that in High income: nonOECD?
Your answer should be compact. 1.82. What is the ratio of the % of adult population in 2004 in High income to that in High income: OECD?
Offer a very short reply. 0.91. What is the ratio of the % of adult population of 2005 in High income to that in High income: OECD?
Your answer should be compact. 0.78. What is the ratio of the % of adult population in 2006 in High income to that in High income: OECD?
Offer a very short reply. 0.8. What is the ratio of the % of adult population of 2007 in High income to that in High income: OECD?
Make the answer very short. 0.74. What is the ratio of the % of adult population in 2004 in High income to that in Latin America(all income levels)?
Your response must be concise. 0.72. What is the ratio of the % of adult population in 2005 in High income to that in Latin America(all income levels)?
Your response must be concise. 0.95. What is the ratio of the % of adult population in 2006 in High income to that in Latin America(all income levels)?
Give a very brief answer. 0.87. What is the ratio of the % of adult population of 2007 in High income to that in Latin America(all income levels)?
Keep it short and to the point. 0.77. What is the ratio of the % of adult population of 2004 in High income: nonOECD to that in High income: OECD?
Give a very brief answer. 0.73. What is the ratio of the % of adult population in 2005 in High income: nonOECD to that in High income: OECD?
Provide a succinct answer. 0.45. What is the ratio of the % of adult population in 2006 in High income: nonOECD to that in High income: OECD?
Your answer should be compact. 0.49. What is the ratio of the % of adult population of 2007 in High income: nonOECD to that in High income: OECD?
Offer a very short reply. 0.41. What is the ratio of the % of adult population of 2004 in High income: nonOECD to that in Latin America(all income levels)?
Provide a succinct answer. 0.58. What is the ratio of the % of adult population in 2005 in High income: nonOECD to that in Latin America(all income levels)?
Offer a very short reply. 0.55. What is the ratio of the % of adult population of 2006 in High income: nonOECD to that in Latin America(all income levels)?
Offer a terse response. 0.54. What is the ratio of the % of adult population of 2007 in High income: nonOECD to that in Latin America(all income levels)?
Your answer should be compact. 0.42. What is the ratio of the % of adult population of 2004 in High income: OECD to that in Latin America(all income levels)?
Your answer should be very brief. 0.79. What is the ratio of the % of adult population in 2005 in High income: OECD to that in Latin America(all income levels)?
Offer a very short reply. 1.22. What is the ratio of the % of adult population of 2006 in High income: OECD to that in Latin America(all income levels)?
Keep it short and to the point. 1.09. What is the ratio of the % of adult population in 2007 in High income: OECD to that in Latin America(all income levels)?
Your answer should be very brief. 1.03. What is the difference between the highest and the second highest % of adult population of 2004?
Your response must be concise. 1.89. What is the difference between the highest and the second highest % of adult population of 2005?
Provide a short and direct response. 1.32. What is the difference between the highest and the second highest % of adult population of 2006?
Make the answer very short. 0.65. What is the difference between the highest and the second highest % of adult population of 2007?
Give a very brief answer. 0.27. What is the difference between the highest and the lowest % of adult population in 2004?
Offer a terse response. 9.04. What is the difference between the highest and the lowest % of adult population in 2005?
Your answer should be compact. 6.82. What is the difference between the highest and the lowest % of adult population in 2006?
Provide a short and direct response. 7.23. What is the difference between the highest and the lowest % of adult population in 2007?
Your answer should be very brief. 7.41. 